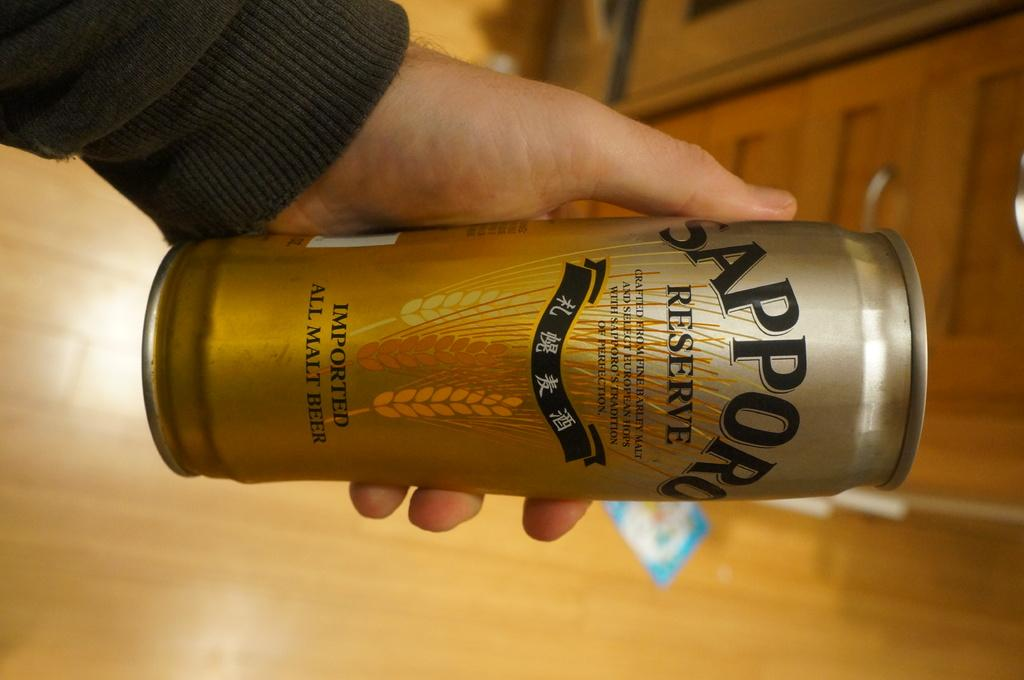<image>
Render a clear and concise summary of the photo. A hand holding a can of Sapporo reserve beer 